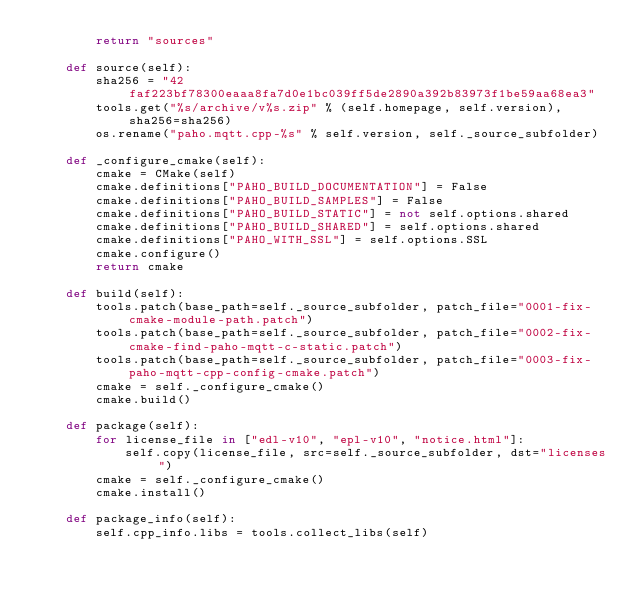<code> <loc_0><loc_0><loc_500><loc_500><_Python_>        return "sources"

    def source(self):
        sha256 = "42faf223bf78300eaaa8fa7d0e1bc039ff5de2890a392b83973f1be59aa68ea3"
        tools.get("%s/archive/v%s.zip" % (self.homepage, self.version), sha256=sha256)
        os.rename("paho.mqtt.cpp-%s" % self.version, self._source_subfolder)

    def _configure_cmake(self):
        cmake = CMake(self)
        cmake.definitions["PAHO_BUILD_DOCUMENTATION"] = False
        cmake.definitions["PAHO_BUILD_SAMPLES"] = False
        cmake.definitions["PAHO_BUILD_STATIC"] = not self.options.shared
        cmake.definitions["PAHO_BUILD_SHARED"] = self.options.shared
        cmake.definitions["PAHO_WITH_SSL"] = self.options.SSL
        cmake.configure()
        return cmake

    def build(self):
        tools.patch(base_path=self._source_subfolder, patch_file="0001-fix-cmake-module-path.patch")
        tools.patch(base_path=self._source_subfolder, patch_file="0002-fix-cmake-find-paho-mqtt-c-static.patch")
        tools.patch(base_path=self._source_subfolder, patch_file="0003-fix-paho-mqtt-cpp-config-cmake.patch")
        cmake = self._configure_cmake()
        cmake.build()

    def package(self):
        for license_file in ["edl-v10", "epl-v10", "notice.html"]:
            self.copy(license_file, src=self._source_subfolder, dst="licenses")
        cmake = self._configure_cmake()
        cmake.install()

    def package_info(self):
        self.cpp_info.libs = tools.collect_libs(self)
</code> 